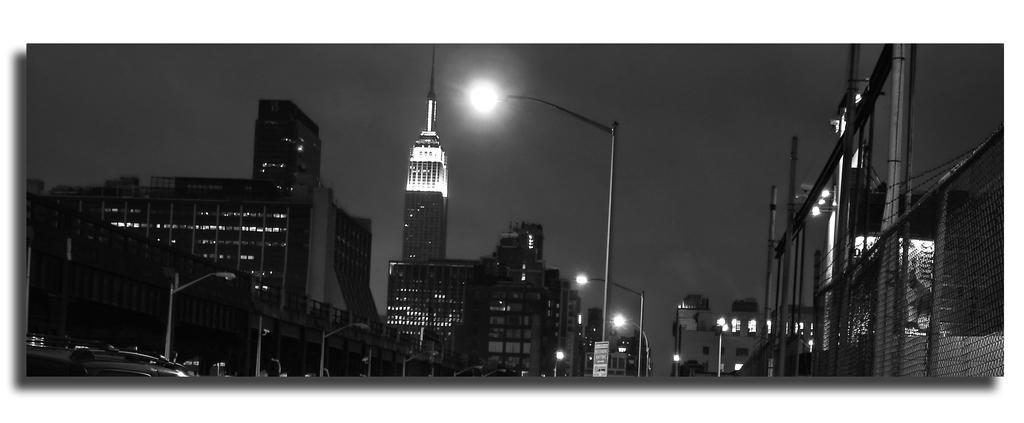In one or two sentences, can you explain what this image depicts? Here we can see black and white image. In the image we can see there are tower buildings, light poles and there are vehicles. Here we can see the fence and the moon. 